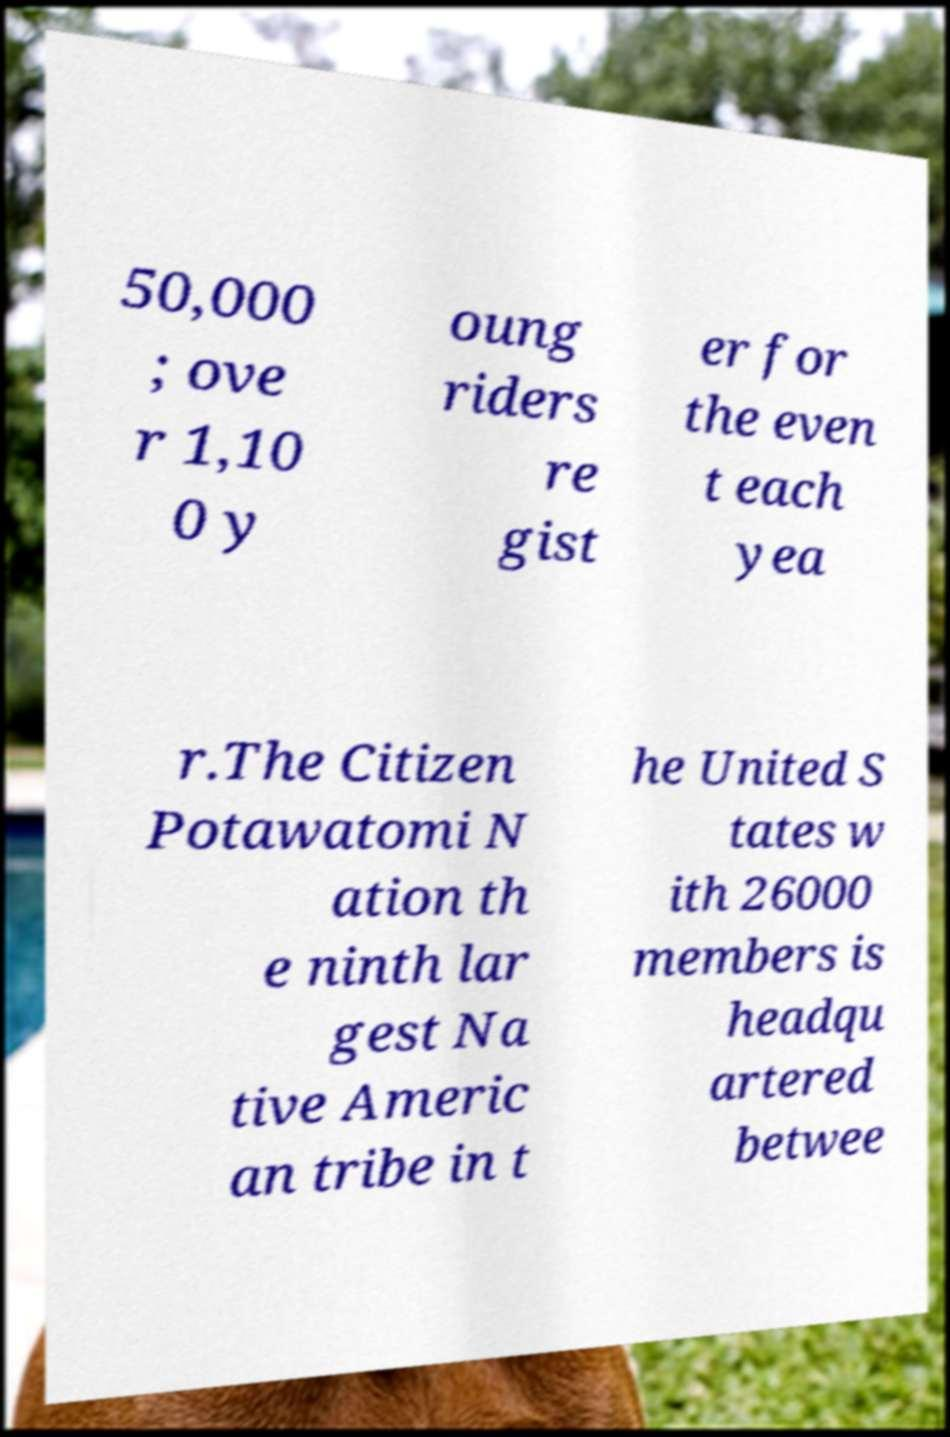There's text embedded in this image that I need extracted. Can you transcribe it verbatim? 50,000 ; ove r 1,10 0 y oung riders re gist er for the even t each yea r.The Citizen Potawatomi N ation th e ninth lar gest Na tive Americ an tribe in t he United S tates w ith 26000 members is headqu artered betwee 